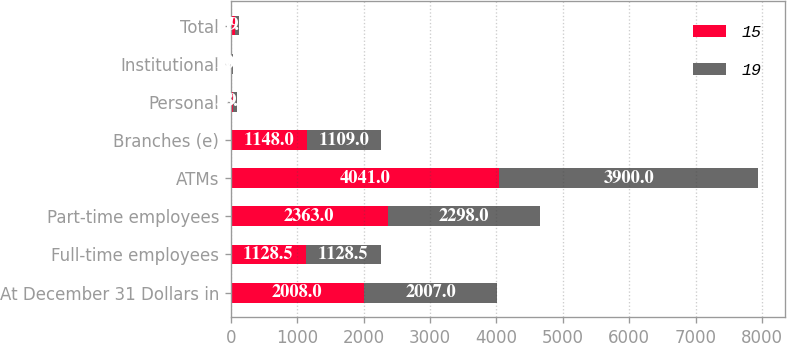Convert chart. <chart><loc_0><loc_0><loc_500><loc_500><stacked_bar_chart><ecel><fcel>At December 31 Dollars in<fcel>Full-time employees<fcel>Part-time employees<fcel>ATMs<fcel>Branches (e)<fcel>Personal<fcel>Institutional<fcel>Total<nl><fcel>15<fcel>2008<fcel>1128.5<fcel>2363<fcel>4041<fcel>1148<fcel>38<fcel>19<fcel>57<nl><fcel>19<fcel>2007<fcel>1128.5<fcel>2298<fcel>3900<fcel>1109<fcel>49<fcel>20<fcel>69<nl></chart> 